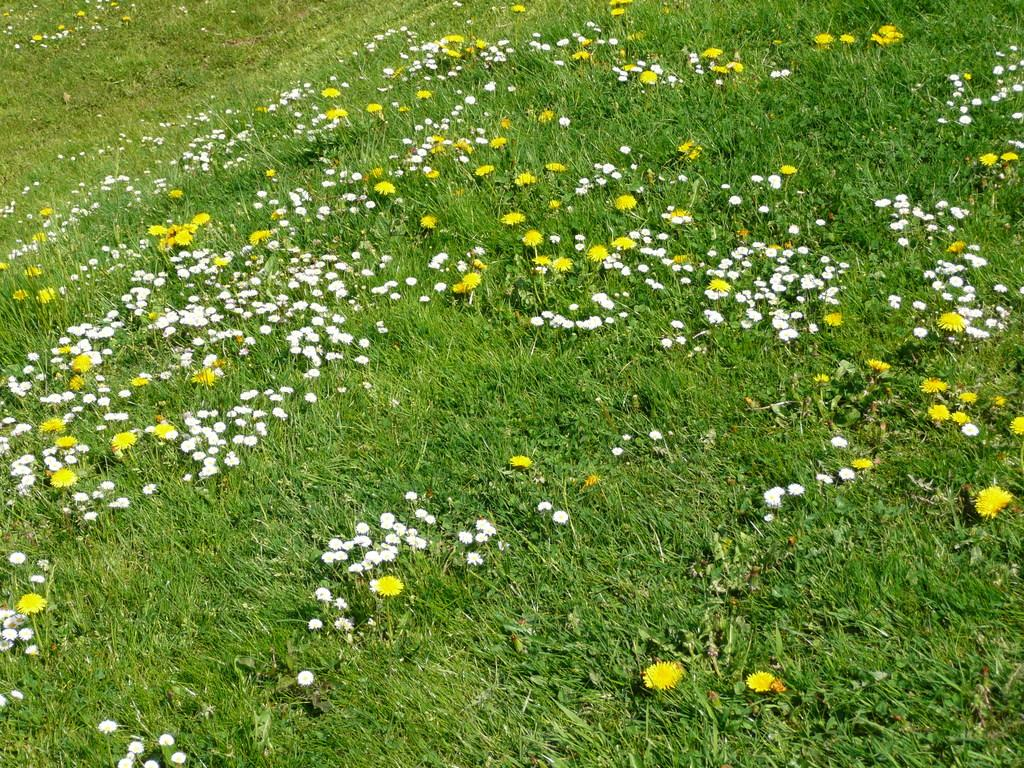What type of vegetation can be seen in the image? There is grass in the image. What other natural elements can be seen in the image? There are flowers in the image. What type of surprise can be seen in the image? There is no surprise present in the image; it features grass and flowers. What type of health benefits can be gained from the flowers in the image? The image does not provide information about the health benefits of the flowers. 